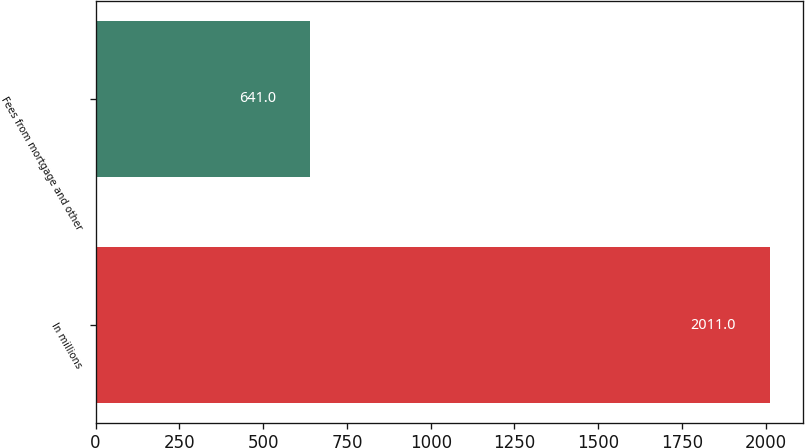Convert chart. <chart><loc_0><loc_0><loc_500><loc_500><bar_chart><fcel>In millions<fcel>Fees from mortgage and other<nl><fcel>2011<fcel>641<nl></chart> 